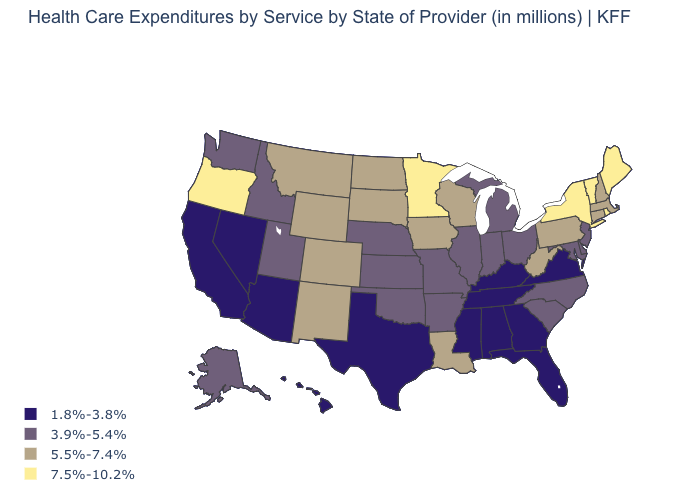Name the states that have a value in the range 7.5%-10.2%?
Quick response, please. Maine, Minnesota, New York, Oregon, Rhode Island, Vermont. What is the value of Connecticut?
Be succinct. 5.5%-7.4%. What is the value of North Dakota?
Quick response, please. 5.5%-7.4%. What is the value of Oklahoma?
Write a very short answer. 3.9%-5.4%. Which states have the highest value in the USA?
Give a very brief answer. Maine, Minnesota, New York, Oregon, Rhode Island, Vermont. Name the states that have a value in the range 1.8%-3.8%?
Answer briefly. Alabama, Arizona, California, Florida, Georgia, Hawaii, Kentucky, Mississippi, Nevada, Tennessee, Texas, Virginia. What is the value of Vermont?
Write a very short answer. 7.5%-10.2%. Name the states that have a value in the range 1.8%-3.8%?
Give a very brief answer. Alabama, Arizona, California, Florida, Georgia, Hawaii, Kentucky, Mississippi, Nevada, Tennessee, Texas, Virginia. Which states have the highest value in the USA?
Answer briefly. Maine, Minnesota, New York, Oregon, Rhode Island, Vermont. Does Maine have the highest value in the Northeast?
Quick response, please. Yes. What is the value of Kansas?
Answer briefly. 3.9%-5.4%. Does Minnesota have a lower value than Florida?
Write a very short answer. No. What is the value of Idaho?
Answer briefly. 3.9%-5.4%. What is the highest value in the MidWest ?
Keep it brief. 7.5%-10.2%. Which states hav the highest value in the MidWest?
Keep it brief. Minnesota. 